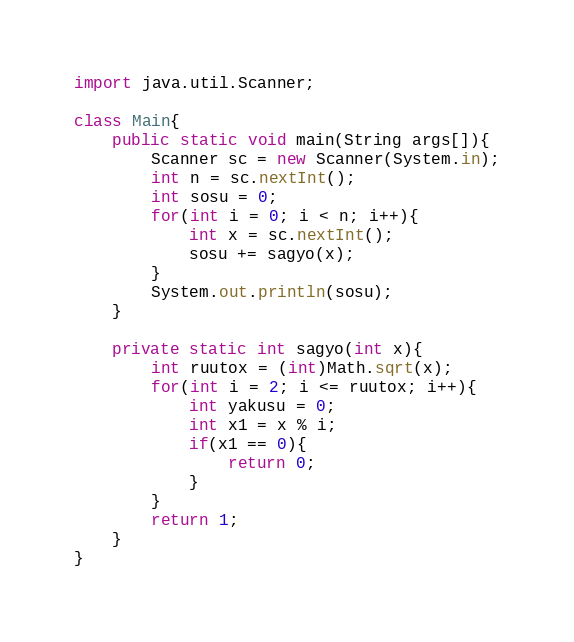Convert code to text. <code><loc_0><loc_0><loc_500><loc_500><_Java_>import java.util.Scanner;

class Main{
    public static void main(String args[]){
        Scanner sc = new Scanner(System.in);
        int n = sc.nextInt();
        int sosu = 0;
        for(int i = 0; i < n; i++){
            int x = sc.nextInt();
        	sosu += sagyo(x);
        }
        System.out.println(sosu);
    }
	
	private static int sagyo(int x){
		int ruutox = (int)Math.sqrt(x);
		for(int i = 2; i <= ruutox; i++){
			int yakusu = 0;
			int x1 = x % i;
			if(x1 == 0){
				return 0;
			}
		}
		return 1;
	}
}
</code> 